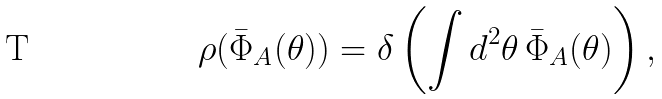<formula> <loc_0><loc_0><loc_500><loc_500>\rho ( \bar { \Phi } _ { A } ( \theta ) ) = \delta \left ( \int d ^ { 2 } \theta \, \bar { \Phi } _ { A } ( \theta ) \right ) ,</formula> 